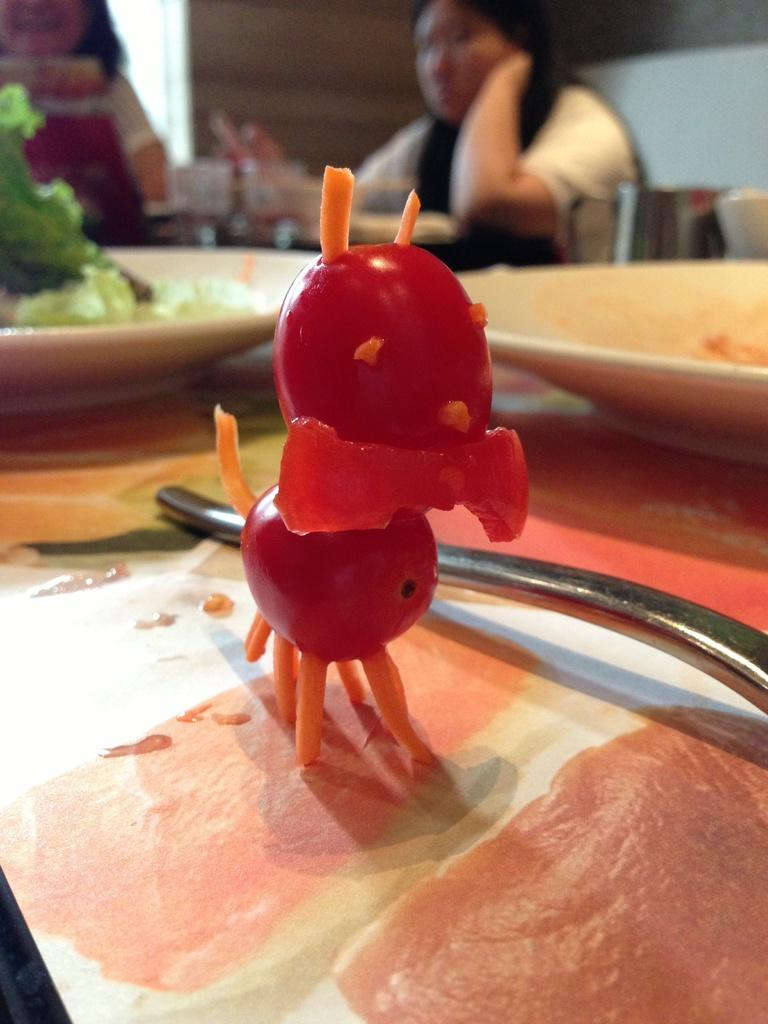What type of objects are present with the plates in the image? There are food items with the plates in the image. How many people can be seen in the image? There are two humans visible in the image. What type of structure is present in the background of the image? There is a wall in the image. What type of grip does the yarn have in the image? There is no yarn present in the image, so it is not possible to determine its grip. What fact is being discussed by the two humans in the image? The image does not provide any information about a fact being discussed by the two humans. 